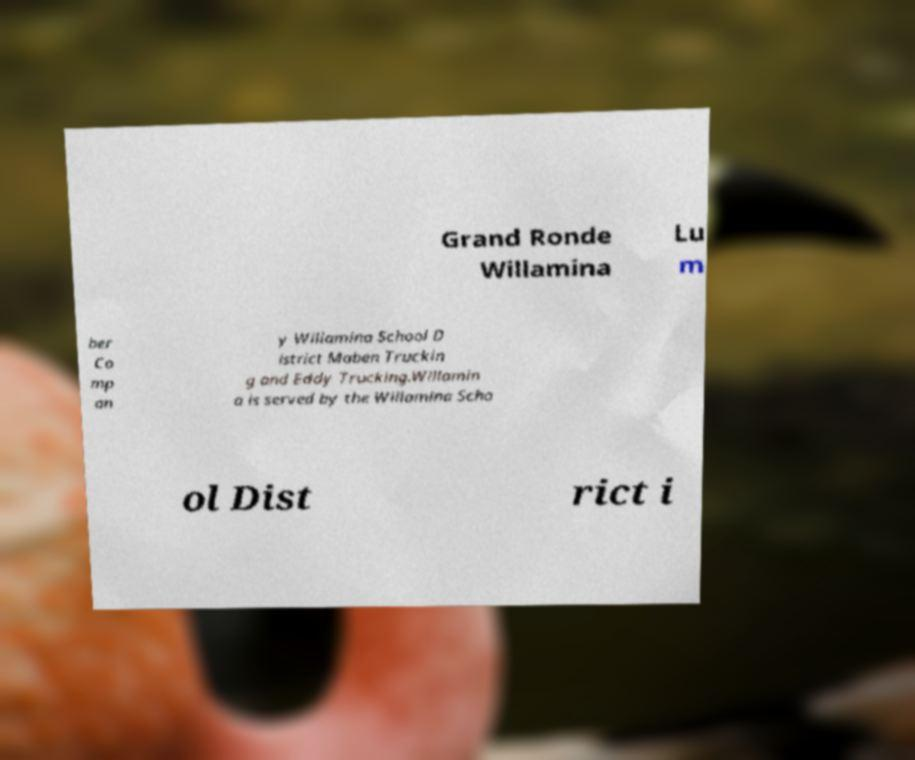What messages or text are displayed in this image? I need them in a readable, typed format. Grand Ronde Willamina Lu m ber Co mp an y Willamina School D istrict Maben Truckin g and Eddy Trucking.Willamin a is served by the Willamina Scho ol Dist rict i 